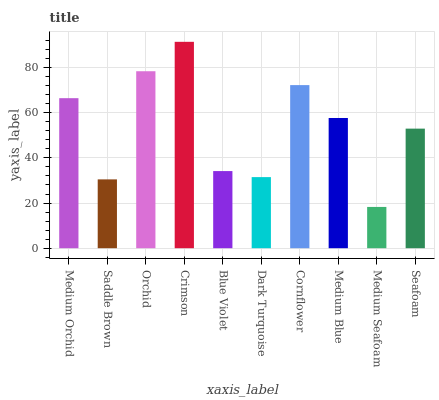Is Medium Seafoam the minimum?
Answer yes or no. Yes. Is Crimson the maximum?
Answer yes or no. Yes. Is Saddle Brown the minimum?
Answer yes or no. No. Is Saddle Brown the maximum?
Answer yes or no. No. Is Medium Orchid greater than Saddle Brown?
Answer yes or no. Yes. Is Saddle Brown less than Medium Orchid?
Answer yes or no. Yes. Is Saddle Brown greater than Medium Orchid?
Answer yes or no. No. Is Medium Orchid less than Saddle Brown?
Answer yes or no. No. Is Medium Blue the high median?
Answer yes or no. Yes. Is Seafoam the low median?
Answer yes or no. Yes. Is Seafoam the high median?
Answer yes or no. No. Is Cornflower the low median?
Answer yes or no. No. 